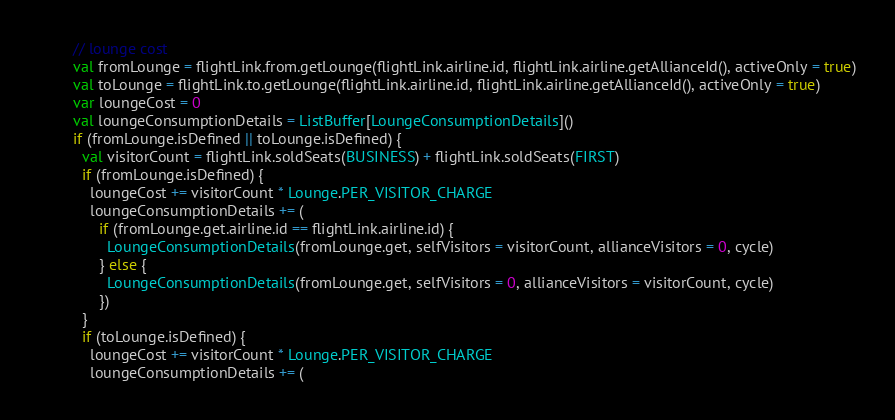<code> <loc_0><loc_0><loc_500><loc_500><_Scala_>
        // lounge cost
        val fromLounge = flightLink.from.getLounge(flightLink.airline.id, flightLink.airline.getAllianceId(), activeOnly = true)
        val toLounge = flightLink.to.getLounge(flightLink.airline.id, flightLink.airline.getAllianceId(), activeOnly = true)
        var loungeCost = 0
        val loungeConsumptionDetails = ListBuffer[LoungeConsumptionDetails]()
        if (fromLounge.isDefined || toLounge.isDefined) {
          val visitorCount = flightLink.soldSeats(BUSINESS) + flightLink.soldSeats(FIRST)
          if (fromLounge.isDefined) {
            loungeCost += visitorCount * Lounge.PER_VISITOR_CHARGE
            loungeConsumptionDetails += (
              if (fromLounge.get.airline.id == flightLink.airline.id) {
                LoungeConsumptionDetails(fromLounge.get, selfVisitors = visitorCount, allianceVisitors = 0, cycle)
              } else {
                LoungeConsumptionDetails(fromLounge.get, selfVisitors = 0, allianceVisitors = visitorCount, cycle)
              })
          }
          if (toLounge.isDefined) {
            loungeCost += visitorCount * Lounge.PER_VISITOR_CHARGE
            loungeConsumptionDetails += (</code> 